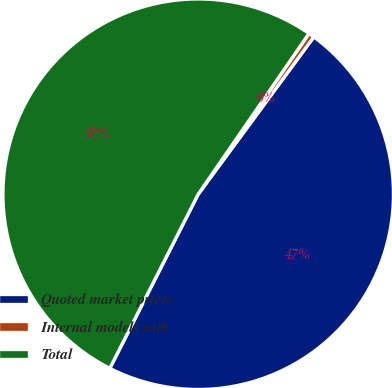Convert chart to OTSL. <chart><loc_0><loc_0><loc_500><loc_500><pie_chart><fcel>Quoted market prices<fcel>Internal models with<fcel>Total<nl><fcel>47.39%<fcel>0.48%<fcel>52.13%<nl></chart> 